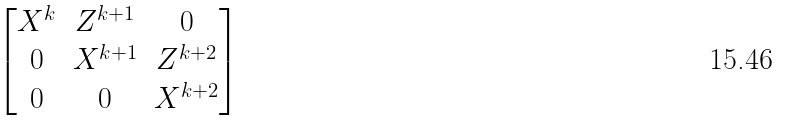<formula> <loc_0><loc_0><loc_500><loc_500>\begin{bmatrix} X ^ { k } & Z ^ { k + 1 } & 0 \\ 0 & X ^ { k + 1 } & Z ^ { k + 2 } \\ 0 & 0 & X ^ { k + 2 } \end{bmatrix}</formula> 